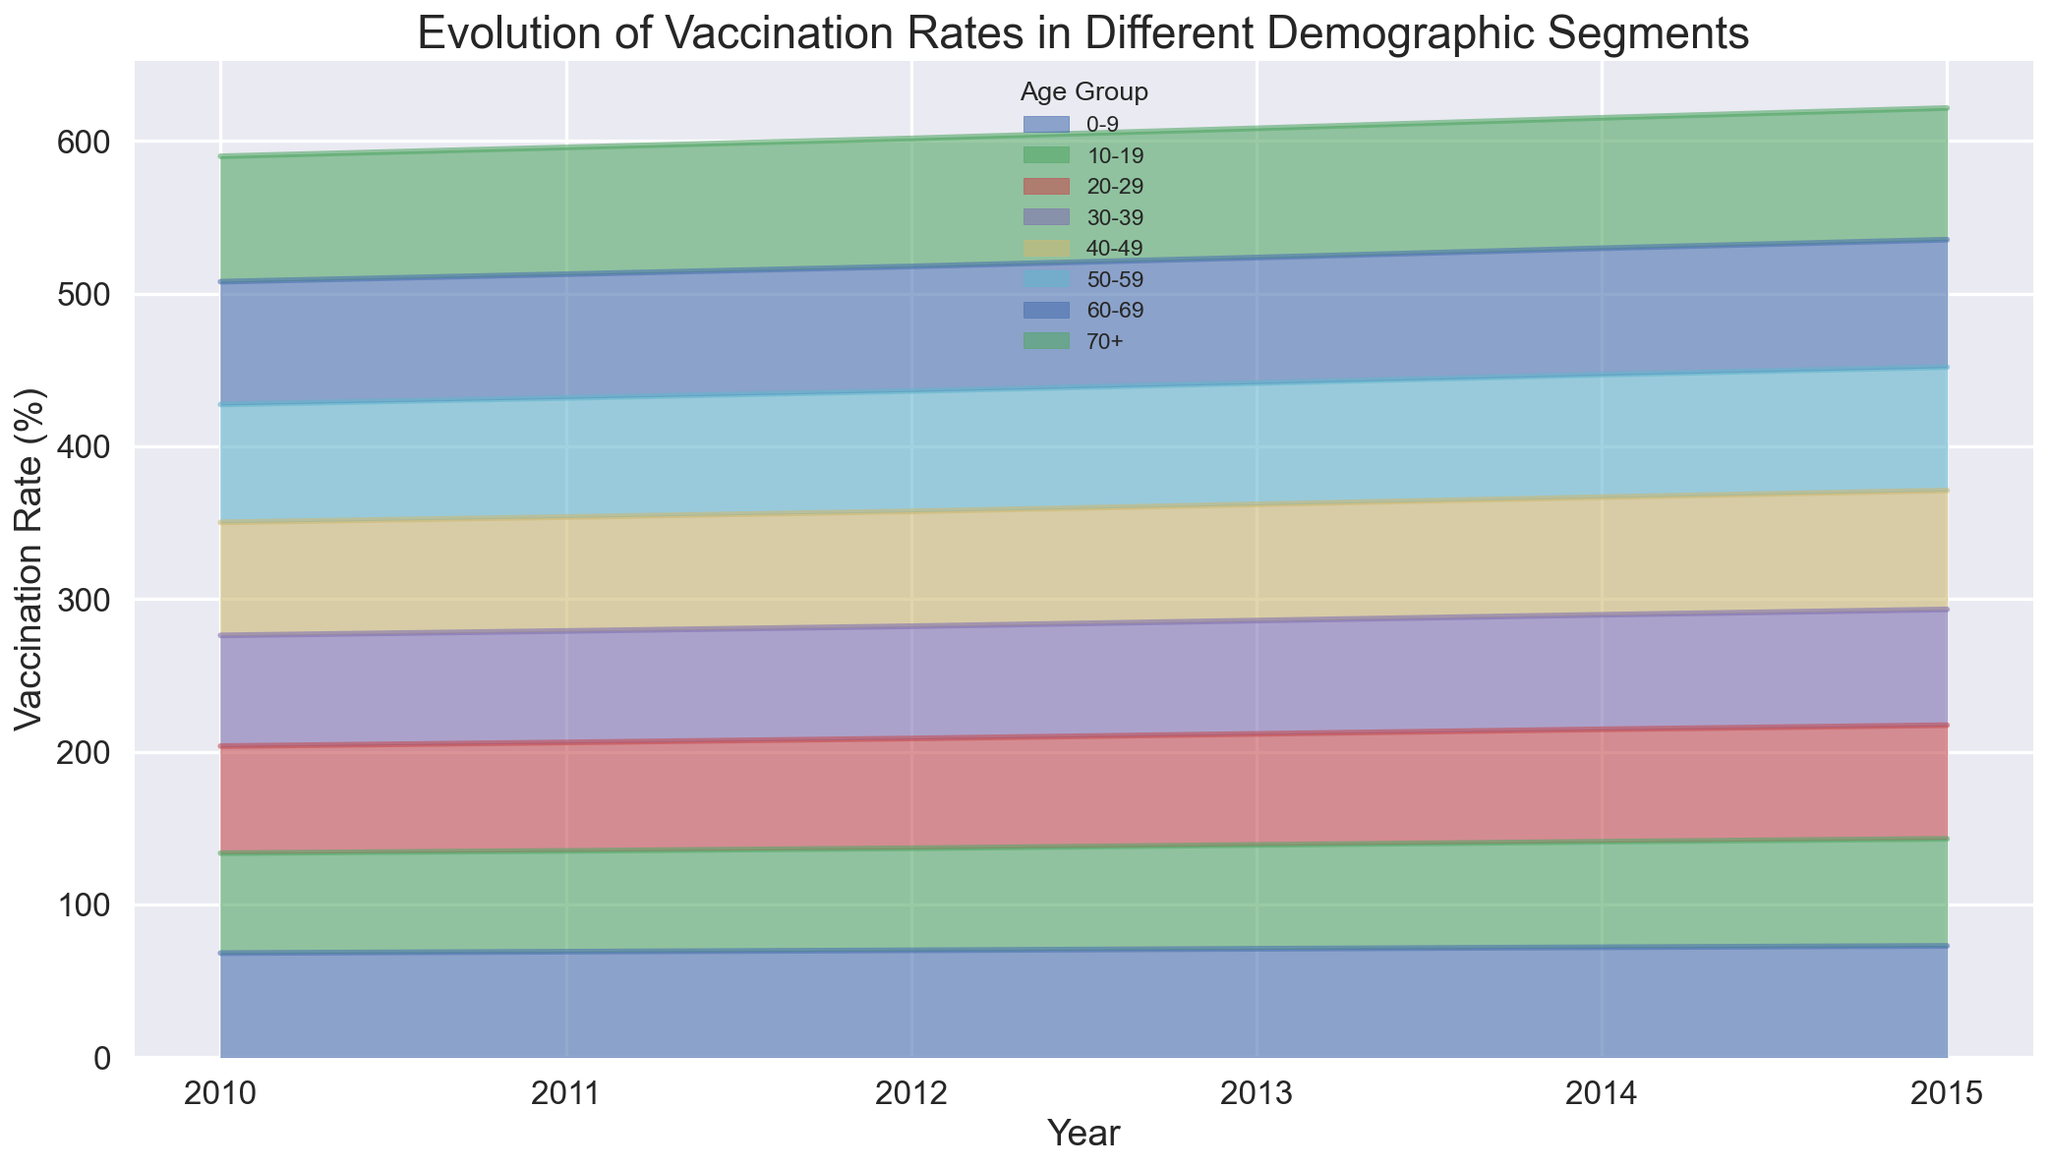What is the highest vaccination rate in 2015? The figure shows the vaccination rate for different age groups across the years. For 2015, observe the highest point among all age groups. The highest point corresponds to the 70+ age group.
Answer: 86.2% Which age group had the lowest vaccination rate in 2013? To find this information, look for the lowest point on the chart for the year 2013. Comparing all the segments, the 10-19 age group had the lowest rate.
Answer: 68.0% How did the vaccination rate for the 0-9 age group change from 2010 to 2015? Locate the 0-9 age group line in the figure and observe its initial and final points from 2010 to 2015. The rate increased from 68.2% to 72.9%.
Answer: Increased by 4.7% Comparing the vaccination rates of the 30-39 and 50-59 age groups in 2012, which group had a higher rate? Find the segments for the 30-39 and 50-59 age groups for the year 2012 and compare their heights. The 50-59 age group had a higher rate.
Answer: 50-59 age group What is the average vaccination rate for the 60-69 age group from 2010 to 2015? To calculate this, find the rates for the 60-69 age group over the given years and calculate their average: (80.4 + 81.0 + 81.6 + 82.2 + 82.8 + 83.4) / 6.
Answer: 81.9% Did the vaccination rate for the 40-49 age group ever exceed 77% before 2015? Observing the 40-49 age group line, check if it exceeds the 77% mark before 2015. It surpasses 77% only in 2015.
Answer: No Which age group showed the most significant increase in vaccination rate from 2010 to 2015? Compare the change in rates for each age group from 2010 to 2015. The 70+ age group shows an increase from 82.1% to 86.2%, which is the largest increase.
Answer: 70+ age group What was the trend of the vaccination rate for the 20-29 age group from 2010 to 2015? Observe the 20-29 age group's area in the figure from 2010 to 2015. The rate consistently increased every year.
Answer: Increasing trend Is there any year where all age groups recorded an increase in vaccination rate? If yes, which year? Carefully examine the lines for all age groups across consecutive years. In 2011, all age groups had an increased vaccination rate compared to 2010.
Answer: 2011 Which age group consistently had the highest vaccination rate each year? Review the highest segments for each year across the chart. The 70+ age group consistently had the highest vaccination rate.
Answer: 70+ age group 